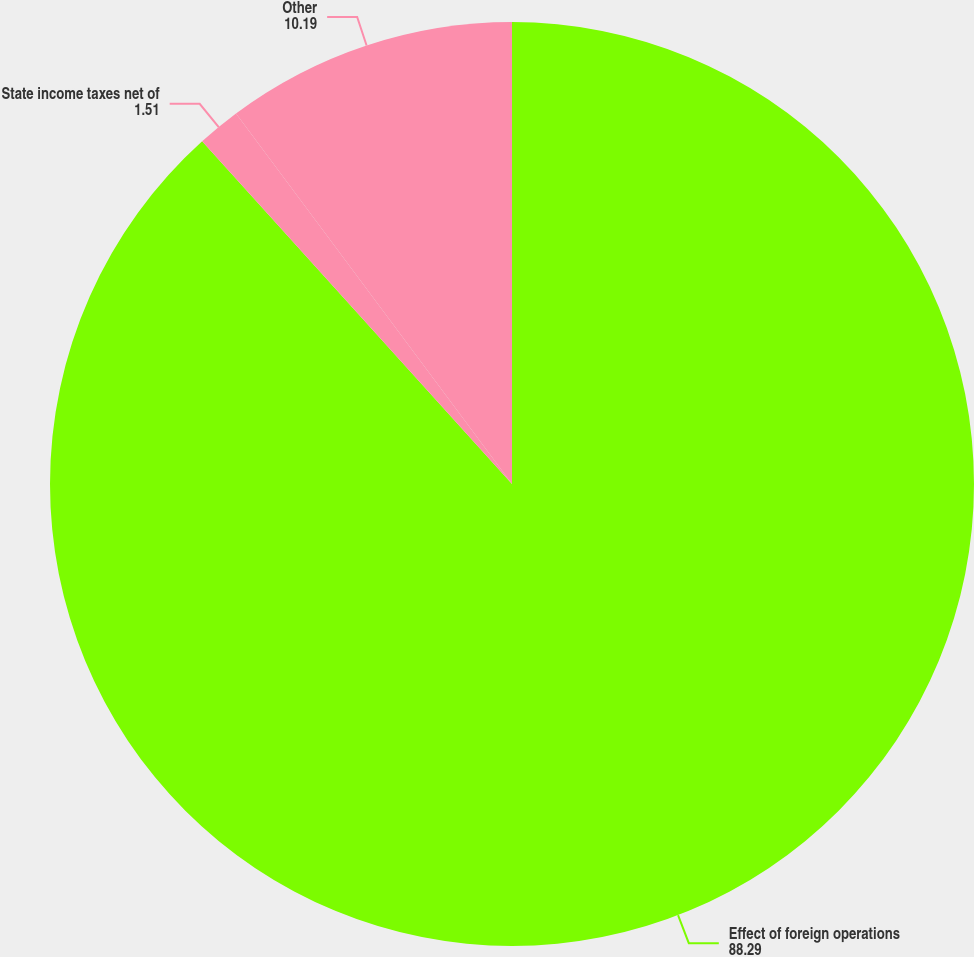<chart> <loc_0><loc_0><loc_500><loc_500><pie_chart><fcel>Effect of foreign operations<fcel>State income taxes net of<fcel>Other<nl><fcel>88.29%<fcel>1.51%<fcel>10.19%<nl></chart> 